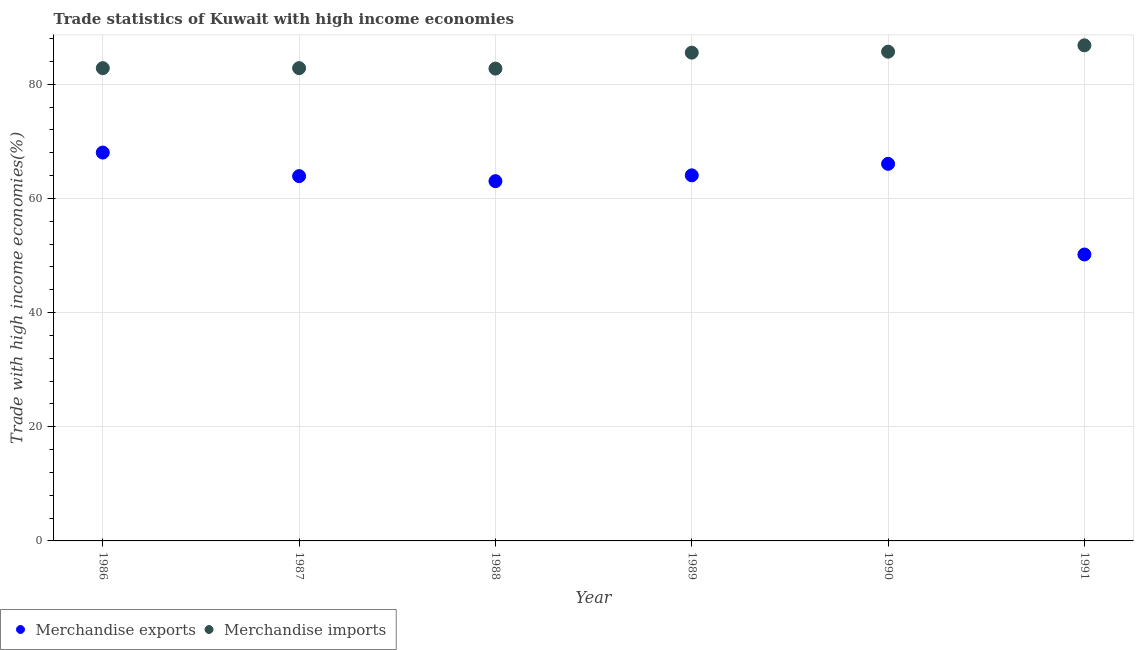Is the number of dotlines equal to the number of legend labels?
Offer a very short reply. Yes. What is the merchandise imports in 1986?
Give a very brief answer. 82.81. Across all years, what is the maximum merchandise exports?
Keep it short and to the point. 68.03. Across all years, what is the minimum merchandise exports?
Provide a short and direct response. 50.17. In which year was the merchandise imports maximum?
Offer a terse response. 1991. What is the total merchandise imports in the graph?
Your response must be concise. 506.41. What is the difference between the merchandise imports in 1988 and that in 1989?
Your answer should be very brief. -2.79. What is the difference between the merchandise exports in 1987 and the merchandise imports in 1990?
Your answer should be compact. -21.8. What is the average merchandise exports per year?
Keep it short and to the point. 62.54. In the year 1989, what is the difference between the merchandise imports and merchandise exports?
Your response must be concise. 21.49. What is the ratio of the merchandise imports in 1986 to that in 1989?
Your response must be concise. 0.97. Is the merchandise imports in 1988 less than that in 1990?
Provide a short and direct response. Yes. Is the difference between the merchandise exports in 1987 and 1988 greater than the difference between the merchandise imports in 1987 and 1988?
Offer a terse response. Yes. What is the difference between the highest and the second highest merchandise exports?
Keep it short and to the point. 1.97. What is the difference between the highest and the lowest merchandise imports?
Your response must be concise. 4.07. In how many years, is the merchandise exports greater than the average merchandise exports taken over all years?
Your answer should be very brief. 5. Is the sum of the merchandise imports in 1989 and 1990 greater than the maximum merchandise exports across all years?
Provide a short and direct response. Yes. Does the merchandise imports monotonically increase over the years?
Ensure brevity in your answer.  No. Is the merchandise imports strictly greater than the merchandise exports over the years?
Keep it short and to the point. Yes. Is the merchandise exports strictly less than the merchandise imports over the years?
Make the answer very short. Yes. How many dotlines are there?
Your response must be concise. 2. How many years are there in the graph?
Make the answer very short. 6. What is the difference between two consecutive major ticks on the Y-axis?
Offer a terse response. 20. Does the graph contain grids?
Provide a succinct answer. Yes. How many legend labels are there?
Provide a short and direct response. 2. What is the title of the graph?
Your answer should be very brief. Trade statistics of Kuwait with high income economies. Does "Imports" appear as one of the legend labels in the graph?
Offer a very short reply. No. What is the label or title of the Y-axis?
Provide a short and direct response. Trade with high income economies(%). What is the Trade with high income economies(%) of Merchandise exports in 1986?
Provide a short and direct response. 68.03. What is the Trade with high income economies(%) of Merchandise imports in 1986?
Make the answer very short. 82.81. What is the Trade with high income economies(%) of Merchandise exports in 1987?
Offer a very short reply. 63.9. What is the Trade with high income economies(%) in Merchandise imports in 1987?
Your response must be concise. 82.82. What is the Trade with high income economies(%) of Merchandise exports in 1988?
Provide a short and direct response. 63.02. What is the Trade with high income economies(%) of Merchandise imports in 1988?
Offer a terse response. 82.74. What is the Trade with high income economies(%) in Merchandise exports in 1989?
Provide a short and direct response. 64.04. What is the Trade with high income economies(%) of Merchandise imports in 1989?
Ensure brevity in your answer.  85.53. What is the Trade with high income economies(%) of Merchandise exports in 1990?
Keep it short and to the point. 66.05. What is the Trade with high income economies(%) of Merchandise imports in 1990?
Your answer should be very brief. 85.7. What is the Trade with high income economies(%) of Merchandise exports in 1991?
Your answer should be very brief. 50.17. What is the Trade with high income economies(%) in Merchandise imports in 1991?
Provide a succinct answer. 86.81. Across all years, what is the maximum Trade with high income economies(%) of Merchandise exports?
Provide a short and direct response. 68.03. Across all years, what is the maximum Trade with high income economies(%) of Merchandise imports?
Your answer should be compact. 86.81. Across all years, what is the minimum Trade with high income economies(%) of Merchandise exports?
Give a very brief answer. 50.17. Across all years, what is the minimum Trade with high income economies(%) of Merchandise imports?
Give a very brief answer. 82.74. What is the total Trade with high income economies(%) of Merchandise exports in the graph?
Provide a succinct answer. 375.21. What is the total Trade with high income economies(%) of Merchandise imports in the graph?
Give a very brief answer. 506.41. What is the difference between the Trade with high income economies(%) of Merchandise exports in 1986 and that in 1987?
Give a very brief answer. 4.13. What is the difference between the Trade with high income economies(%) of Merchandise imports in 1986 and that in 1987?
Make the answer very short. -0. What is the difference between the Trade with high income economies(%) in Merchandise exports in 1986 and that in 1988?
Keep it short and to the point. 5.01. What is the difference between the Trade with high income economies(%) of Merchandise imports in 1986 and that in 1988?
Provide a succinct answer. 0.08. What is the difference between the Trade with high income economies(%) in Merchandise exports in 1986 and that in 1989?
Keep it short and to the point. 3.99. What is the difference between the Trade with high income economies(%) in Merchandise imports in 1986 and that in 1989?
Give a very brief answer. -2.72. What is the difference between the Trade with high income economies(%) in Merchandise exports in 1986 and that in 1990?
Give a very brief answer. 1.97. What is the difference between the Trade with high income economies(%) of Merchandise imports in 1986 and that in 1990?
Offer a very short reply. -2.89. What is the difference between the Trade with high income economies(%) of Merchandise exports in 1986 and that in 1991?
Your answer should be very brief. 17.85. What is the difference between the Trade with high income economies(%) of Merchandise imports in 1986 and that in 1991?
Give a very brief answer. -4. What is the difference between the Trade with high income economies(%) of Merchandise exports in 1987 and that in 1988?
Offer a terse response. 0.88. What is the difference between the Trade with high income economies(%) of Merchandise imports in 1987 and that in 1988?
Ensure brevity in your answer.  0.08. What is the difference between the Trade with high income economies(%) in Merchandise exports in 1987 and that in 1989?
Ensure brevity in your answer.  -0.14. What is the difference between the Trade with high income economies(%) in Merchandise imports in 1987 and that in 1989?
Your answer should be compact. -2.71. What is the difference between the Trade with high income economies(%) of Merchandise exports in 1987 and that in 1990?
Give a very brief answer. -2.15. What is the difference between the Trade with high income economies(%) of Merchandise imports in 1987 and that in 1990?
Ensure brevity in your answer.  -2.88. What is the difference between the Trade with high income economies(%) of Merchandise exports in 1987 and that in 1991?
Provide a short and direct response. 13.73. What is the difference between the Trade with high income economies(%) in Merchandise imports in 1987 and that in 1991?
Ensure brevity in your answer.  -4. What is the difference between the Trade with high income economies(%) of Merchandise exports in 1988 and that in 1989?
Provide a short and direct response. -1.02. What is the difference between the Trade with high income economies(%) of Merchandise imports in 1988 and that in 1989?
Provide a succinct answer. -2.79. What is the difference between the Trade with high income economies(%) in Merchandise exports in 1988 and that in 1990?
Provide a short and direct response. -3.03. What is the difference between the Trade with high income economies(%) of Merchandise imports in 1988 and that in 1990?
Offer a very short reply. -2.96. What is the difference between the Trade with high income economies(%) of Merchandise exports in 1988 and that in 1991?
Your response must be concise. 12.85. What is the difference between the Trade with high income economies(%) in Merchandise imports in 1988 and that in 1991?
Provide a short and direct response. -4.07. What is the difference between the Trade with high income economies(%) of Merchandise exports in 1989 and that in 1990?
Ensure brevity in your answer.  -2.02. What is the difference between the Trade with high income economies(%) in Merchandise imports in 1989 and that in 1990?
Give a very brief answer. -0.17. What is the difference between the Trade with high income economies(%) in Merchandise exports in 1989 and that in 1991?
Provide a succinct answer. 13.87. What is the difference between the Trade with high income economies(%) in Merchandise imports in 1989 and that in 1991?
Give a very brief answer. -1.28. What is the difference between the Trade with high income economies(%) of Merchandise exports in 1990 and that in 1991?
Your response must be concise. 15.88. What is the difference between the Trade with high income economies(%) in Merchandise imports in 1990 and that in 1991?
Make the answer very short. -1.11. What is the difference between the Trade with high income economies(%) in Merchandise exports in 1986 and the Trade with high income economies(%) in Merchandise imports in 1987?
Offer a very short reply. -14.79. What is the difference between the Trade with high income economies(%) in Merchandise exports in 1986 and the Trade with high income economies(%) in Merchandise imports in 1988?
Your response must be concise. -14.71. What is the difference between the Trade with high income economies(%) of Merchandise exports in 1986 and the Trade with high income economies(%) of Merchandise imports in 1989?
Your answer should be compact. -17.5. What is the difference between the Trade with high income economies(%) of Merchandise exports in 1986 and the Trade with high income economies(%) of Merchandise imports in 1990?
Provide a short and direct response. -17.67. What is the difference between the Trade with high income economies(%) of Merchandise exports in 1986 and the Trade with high income economies(%) of Merchandise imports in 1991?
Your answer should be compact. -18.78. What is the difference between the Trade with high income economies(%) of Merchandise exports in 1987 and the Trade with high income economies(%) of Merchandise imports in 1988?
Offer a very short reply. -18.84. What is the difference between the Trade with high income economies(%) in Merchandise exports in 1987 and the Trade with high income economies(%) in Merchandise imports in 1989?
Your answer should be very brief. -21.63. What is the difference between the Trade with high income economies(%) in Merchandise exports in 1987 and the Trade with high income economies(%) in Merchandise imports in 1990?
Give a very brief answer. -21.8. What is the difference between the Trade with high income economies(%) in Merchandise exports in 1987 and the Trade with high income economies(%) in Merchandise imports in 1991?
Offer a terse response. -22.91. What is the difference between the Trade with high income economies(%) of Merchandise exports in 1988 and the Trade with high income economies(%) of Merchandise imports in 1989?
Make the answer very short. -22.51. What is the difference between the Trade with high income economies(%) of Merchandise exports in 1988 and the Trade with high income economies(%) of Merchandise imports in 1990?
Your answer should be very brief. -22.68. What is the difference between the Trade with high income economies(%) of Merchandise exports in 1988 and the Trade with high income economies(%) of Merchandise imports in 1991?
Your answer should be compact. -23.79. What is the difference between the Trade with high income economies(%) in Merchandise exports in 1989 and the Trade with high income economies(%) in Merchandise imports in 1990?
Offer a very short reply. -21.66. What is the difference between the Trade with high income economies(%) in Merchandise exports in 1989 and the Trade with high income economies(%) in Merchandise imports in 1991?
Your response must be concise. -22.77. What is the difference between the Trade with high income economies(%) in Merchandise exports in 1990 and the Trade with high income economies(%) in Merchandise imports in 1991?
Your answer should be very brief. -20.76. What is the average Trade with high income economies(%) in Merchandise exports per year?
Keep it short and to the point. 62.54. What is the average Trade with high income economies(%) in Merchandise imports per year?
Provide a succinct answer. 84.4. In the year 1986, what is the difference between the Trade with high income economies(%) of Merchandise exports and Trade with high income economies(%) of Merchandise imports?
Your answer should be very brief. -14.79. In the year 1987, what is the difference between the Trade with high income economies(%) in Merchandise exports and Trade with high income economies(%) in Merchandise imports?
Your answer should be compact. -18.91. In the year 1988, what is the difference between the Trade with high income economies(%) of Merchandise exports and Trade with high income economies(%) of Merchandise imports?
Offer a very short reply. -19.72. In the year 1989, what is the difference between the Trade with high income economies(%) in Merchandise exports and Trade with high income economies(%) in Merchandise imports?
Keep it short and to the point. -21.49. In the year 1990, what is the difference between the Trade with high income economies(%) in Merchandise exports and Trade with high income economies(%) in Merchandise imports?
Your answer should be very brief. -19.65. In the year 1991, what is the difference between the Trade with high income economies(%) in Merchandise exports and Trade with high income economies(%) in Merchandise imports?
Keep it short and to the point. -36.64. What is the ratio of the Trade with high income economies(%) in Merchandise exports in 1986 to that in 1987?
Keep it short and to the point. 1.06. What is the ratio of the Trade with high income economies(%) in Merchandise exports in 1986 to that in 1988?
Give a very brief answer. 1.08. What is the ratio of the Trade with high income economies(%) of Merchandise imports in 1986 to that in 1988?
Your response must be concise. 1. What is the ratio of the Trade with high income economies(%) of Merchandise exports in 1986 to that in 1989?
Your response must be concise. 1.06. What is the ratio of the Trade with high income economies(%) of Merchandise imports in 1986 to that in 1989?
Keep it short and to the point. 0.97. What is the ratio of the Trade with high income economies(%) in Merchandise exports in 1986 to that in 1990?
Keep it short and to the point. 1.03. What is the ratio of the Trade with high income economies(%) in Merchandise imports in 1986 to that in 1990?
Make the answer very short. 0.97. What is the ratio of the Trade with high income economies(%) in Merchandise exports in 1986 to that in 1991?
Provide a succinct answer. 1.36. What is the ratio of the Trade with high income economies(%) of Merchandise imports in 1986 to that in 1991?
Offer a very short reply. 0.95. What is the ratio of the Trade with high income economies(%) in Merchandise exports in 1987 to that in 1988?
Provide a succinct answer. 1.01. What is the ratio of the Trade with high income economies(%) of Merchandise imports in 1987 to that in 1988?
Give a very brief answer. 1. What is the ratio of the Trade with high income economies(%) of Merchandise imports in 1987 to that in 1989?
Provide a short and direct response. 0.97. What is the ratio of the Trade with high income economies(%) of Merchandise exports in 1987 to that in 1990?
Provide a short and direct response. 0.97. What is the ratio of the Trade with high income economies(%) in Merchandise imports in 1987 to that in 1990?
Ensure brevity in your answer.  0.97. What is the ratio of the Trade with high income economies(%) of Merchandise exports in 1987 to that in 1991?
Offer a terse response. 1.27. What is the ratio of the Trade with high income economies(%) in Merchandise imports in 1987 to that in 1991?
Keep it short and to the point. 0.95. What is the ratio of the Trade with high income economies(%) of Merchandise exports in 1988 to that in 1989?
Your answer should be compact. 0.98. What is the ratio of the Trade with high income economies(%) in Merchandise imports in 1988 to that in 1989?
Your response must be concise. 0.97. What is the ratio of the Trade with high income economies(%) in Merchandise exports in 1988 to that in 1990?
Keep it short and to the point. 0.95. What is the ratio of the Trade with high income economies(%) of Merchandise imports in 1988 to that in 1990?
Your answer should be very brief. 0.97. What is the ratio of the Trade with high income economies(%) in Merchandise exports in 1988 to that in 1991?
Offer a very short reply. 1.26. What is the ratio of the Trade with high income economies(%) in Merchandise imports in 1988 to that in 1991?
Your answer should be very brief. 0.95. What is the ratio of the Trade with high income economies(%) of Merchandise exports in 1989 to that in 1990?
Ensure brevity in your answer.  0.97. What is the ratio of the Trade with high income economies(%) of Merchandise exports in 1989 to that in 1991?
Your answer should be very brief. 1.28. What is the ratio of the Trade with high income economies(%) of Merchandise exports in 1990 to that in 1991?
Your answer should be very brief. 1.32. What is the ratio of the Trade with high income economies(%) of Merchandise imports in 1990 to that in 1991?
Offer a terse response. 0.99. What is the difference between the highest and the second highest Trade with high income economies(%) in Merchandise exports?
Ensure brevity in your answer.  1.97. What is the difference between the highest and the second highest Trade with high income economies(%) of Merchandise imports?
Keep it short and to the point. 1.11. What is the difference between the highest and the lowest Trade with high income economies(%) of Merchandise exports?
Make the answer very short. 17.85. What is the difference between the highest and the lowest Trade with high income economies(%) of Merchandise imports?
Offer a very short reply. 4.07. 